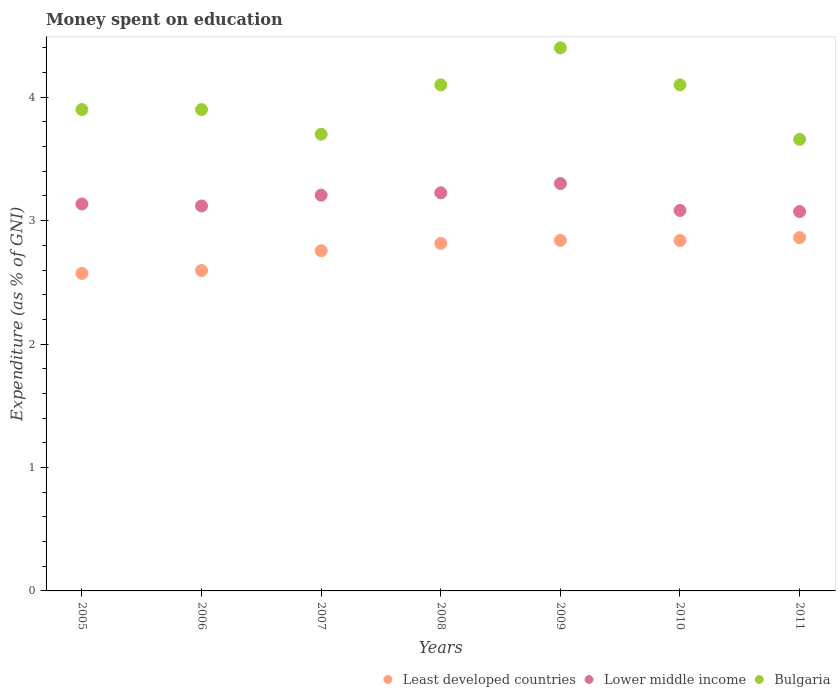How many different coloured dotlines are there?
Provide a succinct answer. 3. What is the amount of money spent on education in Lower middle income in 2009?
Keep it short and to the point. 3.3. Across all years, what is the maximum amount of money spent on education in Lower middle income?
Ensure brevity in your answer.  3.3. Across all years, what is the minimum amount of money spent on education in Lower middle income?
Offer a terse response. 3.07. In which year was the amount of money spent on education in Least developed countries maximum?
Provide a succinct answer. 2011. In which year was the amount of money spent on education in Bulgaria minimum?
Offer a terse response. 2011. What is the total amount of money spent on education in Least developed countries in the graph?
Ensure brevity in your answer.  19.28. What is the difference between the amount of money spent on education in Least developed countries in 2006 and that in 2007?
Your response must be concise. -0.16. What is the difference between the amount of money spent on education in Bulgaria in 2008 and the amount of money spent on education in Least developed countries in 2009?
Offer a very short reply. 1.26. What is the average amount of money spent on education in Least developed countries per year?
Make the answer very short. 2.75. In the year 2011, what is the difference between the amount of money spent on education in Lower middle income and amount of money spent on education in Bulgaria?
Ensure brevity in your answer.  -0.59. What is the ratio of the amount of money spent on education in Lower middle income in 2005 to that in 2011?
Offer a very short reply. 1.02. Is the amount of money spent on education in Bulgaria in 2008 less than that in 2009?
Your answer should be compact. Yes. What is the difference between the highest and the second highest amount of money spent on education in Least developed countries?
Make the answer very short. 0.02. What is the difference between the highest and the lowest amount of money spent on education in Least developed countries?
Offer a very short reply. 0.29. In how many years, is the amount of money spent on education in Least developed countries greater than the average amount of money spent on education in Least developed countries taken over all years?
Your answer should be compact. 5. Is the sum of the amount of money spent on education in Bulgaria in 2005 and 2007 greater than the maximum amount of money spent on education in Least developed countries across all years?
Offer a terse response. Yes. Is it the case that in every year, the sum of the amount of money spent on education in Lower middle income and amount of money spent on education in Bulgaria  is greater than the amount of money spent on education in Least developed countries?
Your answer should be very brief. Yes. Does the amount of money spent on education in Least developed countries monotonically increase over the years?
Ensure brevity in your answer.  No. Is the amount of money spent on education in Lower middle income strictly greater than the amount of money spent on education in Least developed countries over the years?
Keep it short and to the point. Yes. Is the amount of money spent on education in Bulgaria strictly less than the amount of money spent on education in Least developed countries over the years?
Give a very brief answer. No. How many dotlines are there?
Provide a short and direct response. 3. How many years are there in the graph?
Ensure brevity in your answer.  7. Are the values on the major ticks of Y-axis written in scientific E-notation?
Your response must be concise. No. Where does the legend appear in the graph?
Keep it short and to the point. Bottom right. What is the title of the graph?
Make the answer very short. Money spent on education. What is the label or title of the X-axis?
Keep it short and to the point. Years. What is the label or title of the Y-axis?
Make the answer very short. Expenditure (as % of GNI). What is the Expenditure (as % of GNI) of Least developed countries in 2005?
Your answer should be very brief. 2.57. What is the Expenditure (as % of GNI) of Lower middle income in 2005?
Your answer should be very brief. 3.14. What is the Expenditure (as % of GNI) in Least developed countries in 2006?
Provide a short and direct response. 2.6. What is the Expenditure (as % of GNI) in Lower middle income in 2006?
Your response must be concise. 3.12. What is the Expenditure (as % of GNI) in Least developed countries in 2007?
Ensure brevity in your answer.  2.76. What is the Expenditure (as % of GNI) in Lower middle income in 2007?
Make the answer very short. 3.21. What is the Expenditure (as % of GNI) in Least developed countries in 2008?
Your response must be concise. 2.82. What is the Expenditure (as % of GNI) of Lower middle income in 2008?
Make the answer very short. 3.23. What is the Expenditure (as % of GNI) in Bulgaria in 2008?
Ensure brevity in your answer.  4.1. What is the Expenditure (as % of GNI) in Least developed countries in 2009?
Your response must be concise. 2.84. What is the Expenditure (as % of GNI) in Lower middle income in 2009?
Ensure brevity in your answer.  3.3. What is the Expenditure (as % of GNI) of Least developed countries in 2010?
Your answer should be compact. 2.84. What is the Expenditure (as % of GNI) in Lower middle income in 2010?
Your answer should be compact. 3.08. What is the Expenditure (as % of GNI) in Bulgaria in 2010?
Offer a very short reply. 4.1. What is the Expenditure (as % of GNI) of Least developed countries in 2011?
Provide a short and direct response. 2.86. What is the Expenditure (as % of GNI) of Lower middle income in 2011?
Your response must be concise. 3.07. What is the Expenditure (as % of GNI) in Bulgaria in 2011?
Offer a terse response. 3.66. Across all years, what is the maximum Expenditure (as % of GNI) of Least developed countries?
Provide a succinct answer. 2.86. Across all years, what is the maximum Expenditure (as % of GNI) of Lower middle income?
Make the answer very short. 3.3. Across all years, what is the minimum Expenditure (as % of GNI) of Least developed countries?
Offer a terse response. 2.57. Across all years, what is the minimum Expenditure (as % of GNI) of Lower middle income?
Keep it short and to the point. 3.07. Across all years, what is the minimum Expenditure (as % of GNI) of Bulgaria?
Offer a very short reply. 3.66. What is the total Expenditure (as % of GNI) in Least developed countries in the graph?
Your answer should be compact. 19.28. What is the total Expenditure (as % of GNI) in Lower middle income in the graph?
Offer a very short reply. 22.14. What is the total Expenditure (as % of GNI) in Bulgaria in the graph?
Your answer should be very brief. 27.76. What is the difference between the Expenditure (as % of GNI) in Least developed countries in 2005 and that in 2006?
Your answer should be very brief. -0.02. What is the difference between the Expenditure (as % of GNI) in Lower middle income in 2005 and that in 2006?
Offer a very short reply. 0.02. What is the difference between the Expenditure (as % of GNI) of Least developed countries in 2005 and that in 2007?
Your answer should be very brief. -0.18. What is the difference between the Expenditure (as % of GNI) in Lower middle income in 2005 and that in 2007?
Ensure brevity in your answer.  -0.07. What is the difference between the Expenditure (as % of GNI) in Least developed countries in 2005 and that in 2008?
Make the answer very short. -0.24. What is the difference between the Expenditure (as % of GNI) of Lower middle income in 2005 and that in 2008?
Your response must be concise. -0.09. What is the difference between the Expenditure (as % of GNI) in Least developed countries in 2005 and that in 2009?
Offer a very short reply. -0.27. What is the difference between the Expenditure (as % of GNI) in Lower middle income in 2005 and that in 2009?
Keep it short and to the point. -0.17. What is the difference between the Expenditure (as % of GNI) of Bulgaria in 2005 and that in 2009?
Provide a short and direct response. -0.5. What is the difference between the Expenditure (as % of GNI) in Least developed countries in 2005 and that in 2010?
Your response must be concise. -0.27. What is the difference between the Expenditure (as % of GNI) in Lower middle income in 2005 and that in 2010?
Keep it short and to the point. 0.05. What is the difference between the Expenditure (as % of GNI) in Bulgaria in 2005 and that in 2010?
Ensure brevity in your answer.  -0.2. What is the difference between the Expenditure (as % of GNI) of Least developed countries in 2005 and that in 2011?
Offer a terse response. -0.29. What is the difference between the Expenditure (as % of GNI) in Lower middle income in 2005 and that in 2011?
Your answer should be compact. 0.06. What is the difference between the Expenditure (as % of GNI) of Bulgaria in 2005 and that in 2011?
Make the answer very short. 0.24. What is the difference between the Expenditure (as % of GNI) of Least developed countries in 2006 and that in 2007?
Your answer should be very brief. -0.16. What is the difference between the Expenditure (as % of GNI) of Lower middle income in 2006 and that in 2007?
Keep it short and to the point. -0.09. What is the difference between the Expenditure (as % of GNI) of Bulgaria in 2006 and that in 2007?
Your answer should be very brief. 0.2. What is the difference between the Expenditure (as % of GNI) of Least developed countries in 2006 and that in 2008?
Offer a terse response. -0.22. What is the difference between the Expenditure (as % of GNI) in Lower middle income in 2006 and that in 2008?
Provide a short and direct response. -0.11. What is the difference between the Expenditure (as % of GNI) in Least developed countries in 2006 and that in 2009?
Keep it short and to the point. -0.24. What is the difference between the Expenditure (as % of GNI) in Lower middle income in 2006 and that in 2009?
Provide a succinct answer. -0.18. What is the difference between the Expenditure (as % of GNI) in Bulgaria in 2006 and that in 2009?
Your answer should be compact. -0.5. What is the difference between the Expenditure (as % of GNI) in Least developed countries in 2006 and that in 2010?
Offer a very short reply. -0.24. What is the difference between the Expenditure (as % of GNI) in Lower middle income in 2006 and that in 2010?
Make the answer very short. 0.04. What is the difference between the Expenditure (as % of GNI) of Bulgaria in 2006 and that in 2010?
Offer a terse response. -0.2. What is the difference between the Expenditure (as % of GNI) in Least developed countries in 2006 and that in 2011?
Your response must be concise. -0.27. What is the difference between the Expenditure (as % of GNI) of Lower middle income in 2006 and that in 2011?
Your answer should be very brief. 0.05. What is the difference between the Expenditure (as % of GNI) in Bulgaria in 2006 and that in 2011?
Your answer should be compact. 0.24. What is the difference between the Expenditure (as % of GNI) of Least developed countries in 2007 and that in 2008?
Your response must be concise. -0.06. What is the difference between the Expenditure (as % of GNI) in Lower middle income in 2007 and that in 2008?
Give a very brief answer. -0.02. What is the difference between the Expenditure (as % of GNI) of Bulgaria in 2007 and that in 2008?
Keep it short and to the point. -0.4. What is the difference between the Expenditure (as % of GNI) in Least developed countries in 2007 and that in 2009?
Offer a very short reply. -0.08. What is the difference between the Expenditure (as % of GNI) of Lower middle income in 2007 and that in 2009?
Your answer should be very brief. -0.09. What is the difference between the Expenditure (as % of GNI) in Least developed countries in 2007 and that in 2010?
Keep it short and to the point. -0.08. What is the difference between the Expenditure (as % of GNI) in Lower middle income in 2007 and that in 2010?
Provide a succinct answer. 0.12. What is the difference between the Expenditure (as % of GNI) of Bulgaria in 2007 and that in 2010?
Make the answer very short. -0.4. What is the difference between the Expenditure (as % of GNI) in Least developed countries in 2007 and that in 2011?
Your answer should be compact. -0.11. What is the difference between the Expenditure (as % of GNI) of Lower middle income in 2007 and that in 2011?
Your answer should be compact. 0.13. What is the difference between the Expenditure (as % of GNI) in Bulgaria in 2007 and that in 2011?
Give a very brief answer. 0.04. What is the difference between the Expenditure (as % of GNI) of Least developed countries in 2008 and that in 2009?
Provide a succinct answer. -0.02. What is the difference between the Expenditure (as % of GNI) in Lower middle income in 2008 and that in 2009?
Provide a succinct answer. -0.07. What is the difference between the Expenditure (as % of GNI) of Bulgaria in 2008 and that in 2009?
Your response must be concise. -0.3. What is the difference between the Expenditure (as % of GNI) in Least developed countries in 2008 and that in 2010?
Offer a terse response. -0.02. What is the difference between the Expenditure (as % of GNI) in Lower middle income in 2008 and that in 2010?
Provide a short and direct response. 0.14. What is the difference between the Expenditure (as % of GNI) in Bulgaria in 2008 and that in 2010?
Ensure brevity in your answer.  0. What is the difference between the Expenditure (as % of GNI) in Least developed countries in 2008 and that in 2011?
Your response must be concise. -0.05. What is the difference between the Expenditure (as % of GNI) in Lower middle income in 2008 and that in 2011?
Offer a terse response. 0.15. What is the difference between the Expenditure (as % of GNI) of Bulgaria in 2008 and that in 2011?
Provide a short and direct response. 0.44. What is the difference between the Expenditure (as % of GNI) in Least developed countries in 2009 and that in 2010?
Offer a terse response. 0. What is the difference between the Expenditure (as % of GNI) in Lower middle income in 2009 and that in 2010?
Provide a short and direct response. 0.22. What is the difference between the Expenditure (as % of GNI) in Bulgaria in 2009 and that in 2010?
Offer a very short reply. 0.3. What is the difference between the Expenditure (as % of GNI) of Least developed countries in 2009 and that in 2011?
Keep it short and to the point. -0.02. What is the difference between the Expenditure (as % of GNI) of Lower middle income in 2009 and that in 2011?
Offer a terse response. 0.23. What is the difference between the Expenditure (as % of GNI) of Bulgaria in 2009 and that in 2011?
Offer a very short reply. 0.74. What is the difference between the Expenditure (as % of GNI) of Least developed countries in 2010 and that in 2011?
Offer a terse response. -0.02. What is the difference between the Expenditure (as % of GNI) in Lower middle income in 2010 and that in 2011?
Provide a succinct answer. 0.01. What is the difference between the Expenditure (as % of GNI) in Bulgaria in 2010 and that in 2011?
Your answer should be compact. 0.44. What is the difference between the Expenditure (as % of GNI) of Least developed countries in 2005 and the Expenditure (as % of GNI) of Lower middle income in 2006?
Your answer should be compact. -0.55. What is the difference between the Expenditure (as % of GNI) of Least developed countries in 2005 and the Expenditure (as % of GNI) of Bulgaria in 2006?
Provide a succinct answer. -1.33. What is the difference between the Expenditure (as % of GNI) of Lower middle income in 2005 and the Expenditure (as % of GNI) of Bulgaria in 2006?
Your response must be concise. -0.76. What is the difference between the Expenditure (as % of GNI) in Least developed countries in 2005 and the Expenditure (as % of GNI) in Lower middle income in 2007?
Offer a very short reply. -0.63. What is the difference between the Expenditure (as % of GNI) of Least developed countries in 2005 and the Expenditure (as % of GNI) of Bulgaria in 2007?
Offer a very short reply. -1.13. What is the difference between the Expenditure (as % of GNI) in Lower middle income in 2005 and the Expenditure (as % of GNI) in Bulgaria in 2007?
Offer a terse response. -0.56. What is the difference between the Expenditure (as % of GNI) in Least developed countries in 2005 and the Expenditure (as % of GNI) in Lower middle income in 2008?
Provide a short and direct response. -0.65. What is the difference between the Expenditure (as % of GNI) of Least developed countries in 2005 and the Expenditure (as % of GNI) of Bulgaria in 2008?
Make the answer very short. -1.53. What is the difference between the Expenditure (as % of GNI) in Lower middle income in 2005 and the Expenditure (as % of GNI) in Bulgaria in 2008?
Your answer should be very brief. -0.96. What is the difference between the Expenditure (as % of GNI) in Least developed countries in 2005 and the Expenditure (as % of GNI) in Lower middle income in 2009?
Your response must be concise. -0.73. What is the difference between the Expenditure (as % of GNI) in Least developed countries in 2005 and the Expenditure (as % of GNI) in Bulgaria in 2009?
Provide a succinct answer. -1.83. What is the difference between the Expenditure (as % of GNI) in Lower middle income in 2005 and the Expenditure (as % of GNI) in Bulgaria in 2009?
Your response must be concise. -1.26. What is the difference between the Expenditure (as % of GNI) of Least developed countries in 2005 and the Expenditure (as % of GNI) of Lower middle income in 2010?
Provide a short and direct response. -0.51. What is the difference between the Expenditure (as % of GNI) in Least developed countries in 2005 and the Expenditure (as % of GNI) in Bulgaria in 2010?
Provide a short and direct response. -1.53. What is the difference between the Expenditure (as % of GNI) of Lower middle income in 2005 and the Expenditure (as % of GNI) of Bulgaria in 2010?
Your answer should be very brief. -0.96. What is the difference between the Expenditure (as % of GNI) of Least developed countries in 2005 and the Expenditure (as % of GNI) of Lower middle income in 2011?
Your answer should be very brief. -0.5. What is the difference between the Expenditure (as % of GNI) of Least developed countries in 2005 and the Expenditure (as % of GNI) of Bulgaria in 2011?
Your answer should be very brief. -1.09. What is the difference between the Expenditure (as % of GNI) in Lower middle income in 2005 and the Expenditure (as % of GNI) in Bulgaria in 2011?
Your answer should be compact. -0.52. What is the difference between the Expenditure (as % of GNI) in Least developed countries in 2006 and the Expenditure (as % of GNI) in Lower middle income in 2007?
Your response must be concise. -0.61. What is the difference between the Expenditure (as % of GNI) of Least developed countries in 2006 and the Expenditure (as % of GNI) of Bulgaria in 2007?
Provide a succinct answer. -1.1. What is the difference between the Expenditure (as % of GNI) of Lower middle income in 2006 and the Expenditure (as % of GNI) of Bulgaria in 2007?
Offer a very short reply. -0.58. What is the difference between the Expenditure (as % of GNI) in Least developed countries in 2006 and the Expenditure (as % of GNI) in Lower middle income in 2008?
Give a very brief answer. -0.63. What is the difference between the Expenditure (as % of GNI) of Least developed countries in 2006 and the Expenditure (as % of GNI) of Bulgaria in 2008?
Provide a short and direct response. -1.5. What is the difference between the Expenditure (as % of GNI) of Lower middle income in 2006 and the Expenditure (as % of GNI) of Bulgaria in 2008?
Offer a very short reply. -0.98. What is the difference between the Expenditure (as % of GNI) of Least developed countries in 2006 and the Expenditure (as % of GNI) of Lower middle income in 2009?
Offer a very short reply. -0.7. What is the difference between the Expenditure (as % of GNI) in Least developed countries in 2006 and the Expenditure (as % of GNI) in Bulgaria in 2009?
Your answer should be very brief. -1.8. What is the difference between the Expenditure (as % of GNI) in Lower middle income in 2006 and the Expenditure (as % of GNI) in Bulgaria in 2009?
Keep it short and to the point. -1.28. What is the difference between the Expenditure (as % of GNI) in Least developed countries in 2006 and the Expenditure (as % of GNI) in Lower middle income in 2010?
Your response must be concise. -0.49. What is the difference between the Expenditure (as % of GNI) of Least developed countries in 2006 and the Expenditure (as % of GNI) of Bulgaria in 2010?
Provide a short and direct response. -1.5. What is the difference between the Expenditure (as % of GNI) of Lower middle income in 2006 and the Expenditure (as % of GNI) of Bulgaria in 2010?
Make the answer very short. -0.98. What is the difference between the Expenditure (as % of GNI) in Least developed countries in 2006 and the Expenditure (as % of GNI) in Lower middle income in 2011?
Make the answer very short. -0.48. What is the difference between the Expenditure (as % of GNI) of Least developed countries in 2006 and the Expenditure (as % of GNI) of Bulgaria in 2011?
Your answer should be compact. -1.06. What is the difference between the Expenditure (as % of GNI) of Lower middle income in 2006 and the Expenditure (as % of GNI) of Bulgaria in 2011?
Give a very brief answer. -0.54. What is the difference between the Expenditure (as % of GNI) in Least developed countries in 2007 and the Expenditure (as % of GNI) in Lower middle income in 2008?
Give a very brief answer. -0.47. What is the difference between the Expenditure (as % of GNI) of Least developed countries in 2007 and the Expenditure (as % of GNI) of Bulgaria in 2008?
Keep it short and to the point. -1.34. What is the difference between the Expenditure (as % of GNI) of Lower middle income in 2007 and the Expenditure (as % of GNI) of Bulgaria in 2008?
Your answer should be compact. -0.89. What is the difference between the Expenditure (as % of GNI) of Least developed countries in 2007 and the Expenditure (as % of GNI) of Lower middle income in 2009?
Your response must be concise. -0.54. What is the difference between the Expenditure (as % of GNI) in Least developed countries in 2007 and the Expenditure (as % of GNI) in Bulgaria in 2009?
Make the answer very short. -1.64. What is the difference between the Expenditure (as % of GNI) in Lower middle income in 2007 and the Expenditure (as % of GNI) in Bulgaria in 2009?
Offer a terse response. -1.19. What is the difference between the Expenditure (as % of GNI) of Least developed countries in 2007 and the Expenditure (as % of GNI) of Lower middle income in 2010?
Your answer should be compact. -0.33. What is the difference between the Expenditure (as % of GNI) of Least developed countries in 2007 and the Expenditure (as % of GNI) of Bulgaria in 2010?
Provide a succinct answer. -1.34. What is the difference between the Expenditure (as % of GNI) of Lower middle income in 2007 and the Expenditure (as % of GNI) of Bulgaria in 2010?
Keep it short and to the point. -0.89. What is the difference between the Expenditure (as % of GNI) of Least developed countries in 2007 and the Expenditure (as % of GNI) of Lower middle income in 2011?
Your answer should be very brief. -0.32. What is the difference between the Expenditure (as % of GNI) of Least developed countries in 2007 and the Expenditure (as % of GNI) of Bulgaria in 2011?
Offer a terse response. -0.9. What is the difference between the Expenditure (as % of GNI) in Lower middle income in 2007 and the Expenditure (as % of GNI) in Bulgaria in 2011?
Make the answer very short. -0.45. What is the difference between the Expenditure (as % of GNI) of Least developed countries in 2008 and the Expenditure (as % of GNI) of Lower middle income in 2009?
Your answer should be compact. -0.48. What is the difference between the Expenditure (as % of GNI) of Least developed countries in 2008 and the Expenditure (as % of GNI) of Bulgaria in 2009?
Provide a short and direct response. -1.58. What is the difference between the Expenditure (as % of GNI) of Lower middle income in 2008 and the Expenditure (as % of GNI) of Bulgaria in 2009?
Keep it short and to the point. -1.17. What is the difference between the Expenditure (as % of GNI) of Least developed countries in 2008 and the Expenditure (as % of GNI) of Lower middle income in 2010?
Give a very brief answer. -0.27. What is the difference between the Expenditure (as % of GNI) of Least developed countries in 2008 and the Expenditure (as % of GNI) of Bulgaria in 2010?
Make the answer very short. -1.28. What is the difference between the Expenditure (as % of GNI) of Lower middle income in 2008 and the Expenditure (as % of GNI) of Bulgaria in 2010?
Ensure brevity in your answer.  -0.87. What is the difference between the Expenditure (as % of GNI) in Least developed countries in 2008 and the Expenditure (as % of GNI) in Lower middle income in 2011?
Make the answer very short. -0.26. What is the difference between the Expenditure (as % of GNI) of Least developed countries in 2008 and the Expenditure (as % of GNI) of Bulgaria in 2011?
Your answer should be very brief. -0.84. What is the difference between the Expenditure (as % of GNI) in Lower middle income in 2008 and the Expenditure (as % of GNI) in Bulgaria in 2011?
Provide a short and direct response. -0.43. What is the difference between the Expenditure (as % of GNI) in Least developed countries in 2009 and the Expenditure (as % of GNI) in Lower middle income in 2010?
Give a very brief answer. -0.24. What is the difference between the Expenditure (as % of GNI) in Least developed countries in 2009 and the Expenditure (as % of GNI) in Bulgaria in 2010?
Keep it short and to the point. -1.26. What is the difference between the Expenditure (as % of GNI) of Lower middle income in 2009 and the Expenditure (as % of GNI) of Bulgaria in 2010?
Make the answer very short. -0.8. What is the difference between the Expenditure (as % of GNI) of Least developed countries in 2009 and the Expenditure (as % of GNI) of Lower middle income in 2011?
Offer a very short reply. -0.23. What is the difference between the Expenditure (as % of GNI) of Least developed countries in 2009 and the Expenditure (as % of GNI) of Bulgaria in 2011?
Provide a succinct answer. -0.82. What is the difference between the Expenditure (as % of GNI) in Lower middle income in 2009 and the Expenditure (as % of GNI) in Bulgaria in 2011?
Offer a terse response. -0.36. What is the difference between the Expenditure (as % of GNI) of Least developed countries in 2010 and the Expenditure (as % of GNI) of Lower middle income in 2011?
Ensure brevity in your answer.  -0.23. What is the difference between the Expenditure (as % of GNI) in Least developed countries in 2010 and the Expenditure (as % of GNI) in Bulgaria in 2011?
Ensure brevity in your answer.  -0.82. What is the difference between the Expenditure (as % of GNI) in Lower middle income in 2010 and the Expenditure (as % of GNI) in Bulgaria in 2011?
Provide a succinct answer. -0.58. What is the average Expenditure (as % of GNI) in Least developed countries per year?
Offer a very short reply. 2.75. What is the average Expenditure (as % of GNI) of Lower middle income per year?
Offer a very short reply. 3.16. What is the average Expenditure (as % of GNI) of Bulgaria per year?
Your answer should be compact. 3.97. In the year 2005, what is the difference between the Expenditure (as % of GNI) in Least developed countries and Expenditure (as % of GNI) in Lower middle income?
Ensure brevity in your answer.  -0.56. In the year 2005, what is the difference between the Expenditure (as % of GNI) of Least developed countries and Expenditure (as % of GNI) of Bulgaria?
Give a very brief answer. -1.33. In the year 2005, what is the difference between the Expenditure (as % of GNI) of Lower middle income and Expenditure (as % of GNI) of Bulgaria?
Keep it short and to the point. -0.76. In the year 2006, what is the difference between the Expenditure (as % of GNI) in Least developed countries and Expenditure (as % of GNI) in Lower middle income?
Give a very brief answer. -0.52. In the year 2006, what is the difference between the Expenditure (as % of GNI) of Least developed countries and Expenditure (as % of GNI) of Bulgaria?
Your answer should be compact. -1.3. In the year 2006, what is the difference between the Expenditure (as % of GNI) of Lower middle income and Expenditure (as % of GNI) of Bulgaria?
Offer a terse response. -0.78. In the year 2007, what is the difference between the Expenditure (as % of GNI) of Least developed countries and Expenditure (as % of GNI) of Lower middle income?
Your answer should be compact. -0.45. In the year 2007, what is the difference between the Expenditure (as % of GNI) of Least developed countries and Expenditure (as % of GNI) of Bulgaria?
Offer a terse response. -0.94. In the year 2007, what is the difference between the Expenditure (as % of GNI) in Lower middle income and Expenditure (as % of GNI) in Bulgaria?
Provide a short and direct response. -0.49. In the year 2008, what is the difference between the Expenditure (as % of GNI) in Least developed countries and Expenditure (as % of GNI) in Lower middle income?
Your answer should be compact. -0.41. In the year 2008, what is the difference between the Expenditure (as % of GNI) of Least developed countries and Expenditure (as % of GNI) of Bulgaria?
Keep it short and to the point. -1.28. In the year 2008, what is the difference between the Expenditure (as % of GNI) in Lower middle income and Expenditure (as % of GNI) in Bulgaria?
Provide a short and direct response. -0.87. In the year 2009, what is the difference between the Expenditure (as % of GNI) of Least developed countries and Expenditure (as % of GNI) of Lower middle income?
Ensure brevity in your answer.  -0.46. In the year 2009, what is the difference between the Expenditure (as % of GNI) in Least developed countries and Expenditure (as % of GNI) in Bulgaria?
Offer a terse response. -1.56. In the year 2009, what is the difference between the Expenditure (as % of GNI) in Lower middle income and Expenditure (as % of GNI) in Bulgaria?
Your answer should be compact. -1.1. In the year 2010, what is the difference between the Expenditure (as % of GNI) in Least developed countries and Expenditure (as % of GNI) in Lower middle income?
Your answer should be compact. -0.24. In the year 2010, what is the difference between the Expenditure (as % of GNI) of Least developed countries and Expenditure (as % of GNI) of Bulgaria?
Keep it short and to the point. -1.26. In the year 2010, what is the difference between the Expenditure (as % of GNI) of Lower middle income and Expenditure (as % of GNI) of Bulgaria?
Your answer should be compact. -1.02. In the year 2011, what is the difference between the Expenditure (as % of GNI) in Least developed countries and Expenditure (as % of GNI) in Lower middle income?
Make the answer very short. -0.21. In the year 2011, what is the difference between the Expenditure (as % of GNI) of Least developed countries and Expenditure (as % of GNI) of Bulgaria?
Your answer should be compact. -0.8. In the year 2011, what is the difference between the Expenditure (as % of GNI) of Lower middle income and Expenditure (as % of GNI) of Bulgaria?
Make the answer very short. -0.59. What is the ratio of the Expenditure (as % of GNI) of Lower middle income in 2005 to that in 2006?
Offer a very short reply. 1.01. What is the ratio of the Expenditure (as % of GNI) in Bulgaria in 2005 to that in 2006?
Offer a terse response. 1. What is the ratio of the Expenditure (as % of GNI) of Least developed countries in 2005 to that in 2007?
Your response must be concise. 0.93. What is the ratio of the Expenditure (as % of GNI) of Lower middle income in 2005 to that in 2007?
Your answer should be very brief. 0.98. What is the ratio of the Expenditure (as % of GNI) in Bulgaria in 2005 to that in 2007?
Your response must be concise. 1.05. What is the ratio of the Expenditure (as % of GNI) of Least developed countries in 2005 to that in 2008?
Your answer should be compact. 0.91. What is the ratio of the Expenditure (as % of GNI) in Lower middle income in 2005 to that in 2008?
Ensure brevity in your answer.  0.97. What is the ratio of the Expenditure (as % of GNI) in Bulgaria in 2005 to that in 2008?
Provide a succinct answer. 0.95. What is the ratio of the Expenditure (as % of GNI) in Least developed countries in 2005 to that in 2009?
Your response must be concise. 0.91. What is the ratio of the Expenditure (as % of GNI) in Lower middle income in 2005 to that in 2009?
Provide a short and direct response. 0.95. What is the ratio of the Expenditure (as % of GNI) in Bulgaria in 2005 to that in 2009?
Your response must be concise. 0.89. What is the ratio of the Expenditure (as % of GNI) of Least developed countries in 2005 to that in 2010?
Offer a very short reply. 0.91. What is the ratio of the Expenditure (as % of GNI) of Bulgaria in 2005 to that in 2010?
Offer a terse response. 0.95. What is the ratio of the Expenditure (as % of GNI) of Least developed countries in 2005 to that in 2011?
Your answer should be compact. 0.9. What is the ratio of the Expenditure (as % of GNI) in Lower middle income in 2005 to that in 2011?
Your answer should be compact. 1.02. What is the ratio of the Expenditure (as % of GNI) in Bulgaria in 2005 to that in 2011?
Ensure brevity in your answer.  1.07. What is the ratio of the Expenditure (as % of GNI) in Least developed countries in 2006 to that in 2007?
Your response must be concise. 0.94. What is the ratio of the Expenditure (as % of GNI) of Lower middle income in 2006 to that in 2007?
Your answer should be very brief. 0.97. What is the ratio of the Expenditure (as % of GNI) in Bulgaria in 2006 to that in 2007?
Your answer should be compact. 1.05. What is the ratio of the Expenditure (as % of GNI) of Least developed countries in 2006 to that in 2008?
Keep it short and to the point. 0.92. What is the ratio of the Expenditure (as % of GNI) in Lower middle income in 2006 to that in 2008?
Keep it short and to the point. 0.97. What is the ratio of the Expenditure (as % of GNI) in Bulgaria in 2006 to that in 2008?
Make the answer very short. 0.95. What is the ratio of the Expenditure (as % of GNI) of Least developed countries in 2006 to that in 2009?
Ensure brevity in your answer.  0.91. What is the ratio of the Expenditure (as % of GNI) in Lower middle income in 2006 to that in 2009?
Offer a very short reply. 0.94. What is the ratio of the Expenditure (as % of GNI) of Bulgaria in 2006 to that in 2009?
Your answer should be compact. 0.89. What is the ratio of the Expenditure (as % of GNI) in Least developed countries in 2006 to that in 2010?
Offer a terse response. 0.91. What is the ratio of the Expenditure (as % of GNI) in Lower middle income in 2006 to that in 2010?
Provide a short and direct response. 1.01. What is the ratio of the Expenditure (as % of GNI) in Bulgaria in 2006 to that in 2010?
Your response must be concise. 0.95. What is the ratio of the Expenditure (as % of GNI) in Least developed countries in 2006 to that in 2011?
Ensure brevity in your answer.  0.91. What is the ratio of the Expenditure (as % of GNI) of Lower middle income in 2006 to that in 2011?
Your response must be concise. 1.01. What is the ratio of the Expenditure (as % of GNI) of Bulgaria in 2006 to that in 2011?
Make the answer very short. 1.07. What is the ratio of the Expenditure (as % of GNI) of Least developed countries in 2007 to that in 2008?
Ensure brevity in your answer.  0.98. What is the ratio of the Expenditure (as % of GNI) in Lower middle income in 2007 to that in 2008?
Provide a short and direct response. 0.99. What is the ratio of the Expenditure (as % of GNI) in Bulgaria in 2007 to that in 2008?
Your answer should be compact. 0.9. What is the ratio of the Expenditure (as % of GNI) in Least developed countries in 2007 to that in 2009?
Ensure brevity in your answer.  0.97. What is the ratio of the Expenditure (as % of GNI) of Lower middle income in 2007 to that in 2009?
Keep it short and to the point. 0.97. What is the ratio of the Expenditure (as % of GNI) in Bulgaria in 2007 to that in 2009?
Your answer should be very brief. 0.84. What is the ratio of the Expenditure (as % of GNI) in Least developed countries in 2007 to that in 2010?
Provide a succinct answer. 0.97. What is the ratio of the Expenditure (as % of GNI) of Lower middle income in 2007 to that in 2010?
Provide a short and direct response. 1.04. What is the ratio of the Expenditure (as % of GNI) of Bulgaria in 2007 to that in 2010?
Give a very brief answer. 0.9. What is the ratio of the Expenditure (as % of GNI) of Least developed countries in 2007 to that in 2011?
Make the answer very short. 0.96. What is the ratio of the Expenditure (as % of GNI) of Lower middle income in 2007 to that in 2011?
Your answer should be very brief. 1.04. What is the ratio of the Expenditure (as % of GNI) in Bulgaria in 2007 to that in 2011?
Your response must be concise. 1.01. What is the ratio of the Expenditure (as % of GNI) of Lower middle income in 2008 to that in 2009?
Provide a short and direct response. 0.98. What is the ratio of the Expenditure (as % of GNI) in Bulgaria in 2008 to that in 2009?
Offer a very short reply. 0.93. What is the ratio of the Expenditure (as % of GNI) of Least developed countries in 2008 to that in 2010?
Provide a short and direct response. 0.99. What is the ratio of the Expenditure (as % of GNI) in Lower middle income in 2008 to that in 2010?
Provide a succinct answer. 1.05. What is the ratio of the Expenditure (as % of GNI) in Least developed countries in 2008 to that in 2011?
Give a very brief answer. 0.98. What is the ratio of the Expenditure (as % of GNI) of Lower middle income in 2008 to that in 2011?
Your answer should be compact. 1.05. What is the ratio of the Expenditure (as % of GNI) of Bulgaria in 2008 to that in 2011?
Offer a very short reply. 1.12. What is the ratio of the Expenditure (as % of GNI) in Lower middle income in 2009 to that in 2010?
Provide a short and direct response. 1.07. What is the ratio of the Expenditure (as % of GNI) in Bulgaria in 2009 to that in 2010?
Offer a terse response. 1.07. What is the ratio of the Expenditure (as % of GNI) of Least developed countries in 2009 to that in 2011?
Offer a terse response. 0.99. What is the ratio of the Expenditure (as % of GNI) in Lower middle income in 2009 to that in 2011?
Your response must be concise. 1.07. What is the ratio of the Expenditure (as % of GNI) of Bulgaria in 2009 to that in 2011?
Your answer should be compact. 1.2. What is the ratio of the Expenditure (as % of GNI) of Lower middle income in 2010 to that in 2011?
Provide a short and direct response. 1. What is the ratio of the Expenditure (as % of GNI) of Bulgaria in 2010 to that in 2011?
Provide a succinct answer. 1.12. What is the difference between the highest and the second highest Expenditure (as % of GNI) in Least developed countries?
Keep it short and to the point. 0.02. What is the difference between the highest and the second highest Expenditure (as % of GNI) in Lower middle income?
Give a very brief answer. 0.07. What is the difference between the highest and the lowest Expenditure (as % of GNI) in Least developed countries?
Provide a succinct answer. 0.29. What is the difference between the highest and the lowest Expenditure (as % of GNI) of Lower middle income?
Your answer should be very brief. 0.23. What is the difference between the highest and the lowest Expenditure (as % of GNI) of Bulgaria?
Ensure brevity in your answer.  0.74. 